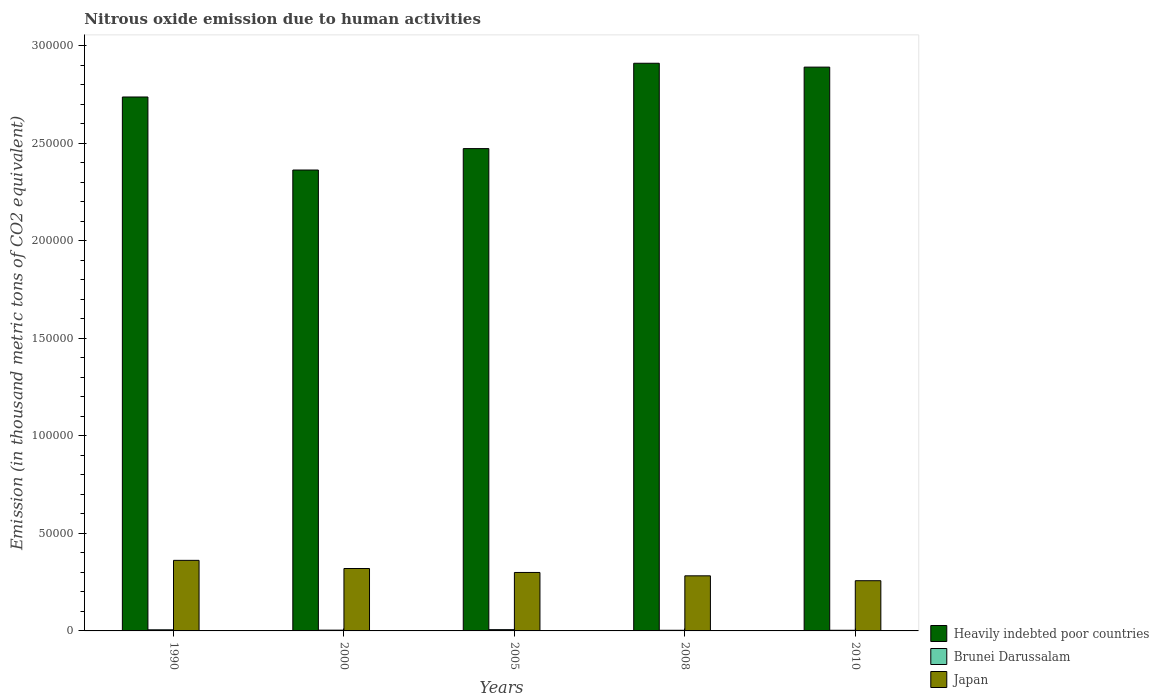How many groups of bars are there?
Your answer should be compact. 5. In how many cases, is the number of bars for a given year not equal to the number of legend labels?
Give a very brief answer. 0. What is the amount of nitrous oxide emitted in Brunei Darussalam in 2000?
Keep it short and to the point. 394.8. Across all years, what is the maximum amount of nitrous oxide emitted in Brunei Darussalam?
Offer a very short reply. 653.7. Across all years, what is the minimum amount of nitrous oxide emitted in Japan?
Offer a very short reply. 2.57e+04. In which year was the amount of nitrous oxide emitted in Japan maximum?
Give a very brief answer. 1990. What is the total amount of nitrous oxide emitted in Japan in the graph?
Your answer should be compact. 1.52e+05. What is the difference between the amount of nitrous oxide emitted in Brunei Darussalam in 2000 and that in 2010?
Offer a terse response. 59.2. What is the difference between the amount of nitrous oxide emitted in Japan in 2000 and the amount of nitrous oxide emitted in Brunei Darussalam in 2005?
Offer a terse response. 3.13e+04. What is the average amount of nitrous oxide emitted in Brunei Darussalam per year?
Your answer should be compact. 457.44. In the year 2000, what is the difference between the amount of nitrous oxide emitted in Brunei Darussalam and amount of nitrous oxide emitted in Japan?
Your answer should be very brief. -3.16e+04. In how many years, is the amount of nitrous oxide emitted in Heavily indebted poor countries greater than 40000 thousand metric tons?
Your answer should be very brief. 5. What is the ratio of the amount of nitrous oxide emitted in Heavily indebted poor countries in 2008 to that in 2010?
Offer a terse response. 1.01. Is the difference between the amount of nitrous oxide emitted in Brunei Darussalam in 2000 and 2010 greater than the difference between the amount of nitrous oxide emitted in Japan in 2000 and 2010?
Your answer should be compact. No. What is the difference between the highest and the second highest amount of nitrous oxide emitted in Brunei Darussalam?
Ensure brevity in your answer.  82.6. What is the difference between the highest and the lowest amount of nitrous oxide emitted in Japan?
Provide a short and direct response. 1.04e+04. Is the sum of the amount of nitrous oxide emitted in Japan in 2000 and 2008 greater than the maximum amount of nitrous oxide emitted in Heavily indebted poor countries across all years?
Offer a terse response. No. What does the 2nd bar from the left in 2010 represents?
Offer a terse response. Brunei Darussalam. How many bars are there?
Your response must be concise. 15. Are all the bars in the graph horizontal?
Provide a succinct answer. No. How many years are there in the graph?
Your response must be concise. 5. What is the difference between two consecutive major ticks on the Y-axis?
Your answer should be compact. 5.00e+04. Are the values on the major ticks of Y-axis written in scientific E-notation?
Ensure brevity in your answer.  No. Does the graph contain grids?
Keep it short and to the point. No. How are the legend labels stacked?
Offer a very short reply. Vertical. What is the title of the graph?
Keep it short and to the point. Nitrous oxide emission due to human activities. Does "Honduras" appear as one of the legend labels in the graph?
Make the answer very short. No. What is the label or title of the X-axis?
Offer a very short reply. Years. What is the label or title of the Y-axis?
Your response must be concise. Emission (in thousand metric tons of CO2 equivalent). What is the Emission (in thousand metric tons of CO2 equivalent) in Heavily indebted poor countries in 1990?
Provide a succinct answer. 2.74e+05. What is the Emission (in thousand metric tons of CO2 equivalent) in Brunei Darussalam in 1990?
Offer a very short reply. 571.1. What is the Emission (in thousand metric tons of CO2 equivalent) of Japan in 1990?
Provide a short and direct response. 3.62e+04. What is the Emission (in thousand metric tons of CO2 equivalent) in Heavily indebted poor countries in 2000?
Give a very brief answer. 2.36e+05. What is the Emission (in thousand metric tons of CO2 equivalent) of Brunei Darussalam in 2000?
Give a very brief answer. 394.8. What is the Emission (in thousand metric tons of CO2 equivalent) in Japan in 2000?
Give a very brief answer. 3.20e+04. What is the Emission (in thousand metric tons of CO2 equivalent) in Heavily indebted poor countries in 2005?
Offer a terse response. 2.47e+05. What is the Emission (in thousand metric tons of CO2 equivalent) in Brunei Darussalam in 2005?
Make the answer very short. 653.7. What is the Emission (in thousand metric tons of CO2 equivalent) in Japan in 2005?
Offer a very short reply. 3.00e+04. What is the Emission (in thousand metric tons of CO2 equivalent) of Heavily indebted poor countries in 2008?
Provide a succinct answer. 2.91e+05. What is the Emission (in thousand metric tons of CO2 equivalent) in Brunei Darussalam in 2008?
Your answer should be compact. 332. What is the Emission (in thousand metric tons of CO2 equivalent) in Japan in 2008?
Ensure brevity in your answer.  2.82e+04. What is the Emission (in thousand metric tons of CO2 equivalent) of Heavily indebted poor countries in 2010?
Provide a short and direct response. 2.89e+05. What is the Emission (in thousand metric tons of CO2 equivalent) in Brunei Darussalam in 2010?
Offer a very short reply. 335.6. What is the Emission (in thousand metric tons of CO2 equivalent) in Japan in 2010?
Keep it short and to the point. 2.57e+04. Across all years, what is the maximum Emission (in thousand metric tons of CO2 equivalent) in Heavily indebted poor countries?
Give a very brief answer. 2.91e+05. Across all years, what is the maximum Emission (in thousand metric tons of CO2 equivalent) of Brunei Darussalam?
Your response must be concise. 653.7. Across all years, what is the maximum Emission (in thousand metric tons of CO2 equivalent) in Japan?
Offer a terse response. 3.62e+04. Across all years, what is the minimum Emission (in thousand metric tons of CO2 equivalent) in Heavily indebted poor countries?
Your answer should be compact. 2.36e+05. Across all years, what is the minimum Emission (in thousand metric tons of CO2 equivalent) of Brunei Darussalam?
Offer a terse response. 332. Across all years, what is the minimum Emission (in thousand metric tons of CO2 equivalent) in Japan?
Make the answer very short. 2.57e+04. What is the total Emission (in thousand metric tons of CO2 equivalent) in Heavily indebted poor countries in the graph?
Your response must be concise. 1.34e+06. What is the total Emission (in thousand metric tons of CO2 equivalent) of Brunei Darussalam in the graph?
Ensure brevity in your answer.  2287.2. What is the total Emission (in thousand metric tons of CO2 equivalent) of Japan in the graph?
Your response must be concise. 1.52e+05. What is the difference between the Emission (in thousand metric tons of CO2 equivalent) of Heavily indebted poor countries in 1990 and that in 2000?
Your answer should be compact. 3.74e+04. What is the difference between the Emission (in thousand metric tons of CO2 equivalent) of Brunei Darussalam in 1990 and that in 2000?
Ensure brevity in your answer.  176.3. What is the difference between the Emission (in thousand metric tons of CO2 equivalent) of Japan in 1990 and that in 2000?
Offer a very short reply. 4179.1. What is the difference between the Emission (in thousand metric tons of CO2 equivalent) of Heavily indebted poor countries in 1990 and that in 2005?
Provide a succinct answer. 2.65e+04. What is the difference between the Emission (in thousand metric tons of CO2 equivalent) of Brunei Darussalam in 1990 and that in 2005?
Your answer should be very brief. -82.6. What is the difference between the Emission (in thousand metric tons of CO2 equivalent) in Japan in 1990 and that in 2005?
Your response must be concise. 6206.6. What is the difference between the Emission (in thousand metric tons of CO2 equivalent) in Heavily indebted poor countries in 1990 and that in 2008?
Give a very brief answer. -1.73e+04. What is the difference between the Emission (in thousand metric tons of CO2 equivalent) in Brunei Darussalam in 1990 and that in 2008?
Your answer should be compact. 239.1. What is the difference between the Emission (in thousand metric tons of CO2 equivalent) of Japan in 1990 and that in 2008?
Give a very brief answer. 7932.2. What is the difference between the Emission (in thousand metric tons of CO2 equivalent) of Heavily indebted poor countries in 1990 and that in 2010?
Your answer should be compact. -1.53e+04. What is the difference between the Emission (in thousand metric tons of CO2 equivalent) of Brunei Darussalam in 1990 and that in 2010?
Provide a short and direct response. 235.5. What is the difference between the Emission (in thousand metric tons of CO2 equivalent) of Japan in 1990 and that in 2010?
Your response must be concise. 1.04e+04. What is the difference between the Emission (in thousand metric tons of CO2 equivalent) in Heavily indebted poor countries in 2000 and that in 2005?
Make the answer very short. -1.10e+04. What is the difference between the Emission (in thousand metric tons of CO2 equivalent) of Brunei Darussalam in 2000 and that in 2005?
Make the answer very short. -258.9. What is the difference between the Emission (in thousand metric tons of CO2 equivalent) of Japan in 2000 and that in 2005?
Give a very brief answer. 2027.5. What is the difference between the Emission (in thousand metric tons of CO2 equivalent) in Heavily indebted poor countries in 2000 and that in 2008?
Provide a short and direct response. -5.47e+04. What is the difference between the Emission (in thousand metric tons of CO2 equivalent) of Brunei Darussalam in 2000 and that in 2008?
Keep it short and to the point. 62.8. What is the difference between the Emission (in thousand metric tons of CO2 equivalent) of Japan in 2000 and that in 2008?
Keep it short and to the point. 3753.1. What is the difference between the Emission (in thousand metric tons of CO2 equivalent) in Heavily indebted poor countries in 2000 and that in 2010?
Ensure brevity in your answer.  -5.28e+04. What is the difference between the Emission (in thousand metric tons of CO2 equivalent) in Brunei Darussalam in 2000 and that in 2010?
Your answer should be very brief. 59.2. What is the difference between the Emission (in thousand metric tons of CO2 equivalent) in Japan in 2000 and that in 2010?
Give a very brief answer. 6256.2. What is the difference between the Emission (in thousand metric tons of CO2 equivalent) of Heavily indebted poor countries in 2005 and that in 2008?
Offer a terse response. -4.38e+04. What is the difference between the Emission (in thousand metric tons of CO2 equivalent) in Brunei Darussalam in 2005 and that in 2008?
Give a very brief answer. 321.7. What is the difference between the Emission (in thousand metric tons of CO2 equivalent) of Japan in 2005 and that in 2008?
Offer a terse response. 1725.6. What is the difference between the Emission (in thousand metric tons of CO2 equivalent) in Heavily indebted poor countries in 2005 and that in 2010?
Your answer should be very brief. -4.18e+04. What is the difference between the Emission (in thousand metric tons of CO2 equivalent) of Brunei Darussalam in 2005 and that in 2010?
Offer a very short reply. 318.1. What is the difference between the Emission (in thousand metric tons of CO2 equivalent) in Japan in 2005 and that in 2010?
Ensure brevity in your answer.  4228.7. What is the difference between the Emission (in thousand metric tons of CO2 equivalent) in Heavily indebted poor countries in 2008 and that in 2010?
Your answer should be compact. 1978. What is the difference between the Emission (in thousand metric tons of CO2 equivalent) in Brunei Darussalam in 2008 and that in 2010?
Give a very brief answer. -3.6. What is the difference between the Emission (in thousand metric tons of CO2 equivalent) in Japan in 2008 and that in 2010?
Offer a terse response. 2503.1. What is the difference between the Emission (in thousand metric tons of CO2 equivalent) of Heavily indebted poor countries in 1990 and the Emission (in thousand metric tons of CO2 equivalent) of Brunei Darussalam in 2000?
Your answer should be compact. 2.73e+05. What is the difference between the Emission (in thousand metric tons of CO2 equivalent) in Heavily indebted poor countries in 1990 and the Emission (in thousand metric tons of CO2 equivalent) in Japan in 2000?
Keep it short and to the point. 2.42e+05. What is the difference between the Emission (in thousand metric tons of CO2 equivalent) in Brunei Darussalam in 1990 and the Emission (in thousand metric tons of CO2 equivalent) in Japan in 2000?
Ensure brevity in your answer.  -3.14e+04. What is the difference between the Emission (in thousand metric tons of CO2 equivalent) of Heavily indebted poor countries in 1990 and the Emission (in thousand metric tons of CO2 equivalent) of Brunei Darussalam in 2005?
Your response must be concise. 2.73e+05. What is the difference between the Emission (in thousand metric tons of CO2 equivalent) of Heavily indebted poor countries in 1990 and the Emission (in thousand metric tons of CO2 equivalent) of Japan in 2005?
Your answer should be very brief. 2.44e+05. What is the difference between the Emission (in thousand metric tons of CO2 equivalent) in Brunei Darussalam in 1990 and the Emission (in thousand metric tons of CO2 equivalent) in Japan in 2005?
Your response must be concise. -2.94e+04. What is the difference between the Emission (in thousand metric tons of CO2 equivalent) of Heavily indebted poor countries in 1990 and the Emission (in thousand metric tons of CO2 equivalent) of Brunei Darussalam in 2008?
Your response must be concise. 2.73e+05. What is the difference between the Emission (in thousand metric tons of CO2 equivalent) in Heavily indebted poor countries in 1990 and the Emission (in thousand metric tons of CO2 equivalent) in Japan in 2008?
Keep it short and to the point. 2.45e+05. What is the difference between the Emission (in thousand metric tons of CO2 equivalent) of Brunei Darussalam in 1990 and the Emission (in thousand metric tons of CO2 equivalent) of Japan in 2008?
Your answer should be very brief. -2.77e+04. What is the difference between the Emission (in thousand metric tons of CO2 equivalent) of Heavily indebted poor countries in 1990 and the Emission (in thousand metric tons of CO2 equivalent) of Brunei Darussalam in 2010?
Offer a terse response. 2.73e+05. What is the difference between the Emission (in thousand metric tons of CO2 equivalent) in Heavily indebted poor countries in 1990 and the Emission (in thousand metric tons of CO2 equivalent) in Japan in 2010?
Your answer should be compact. 2.48e+05. What is the difference between the Emission (in thousand metric tons of CO2 equivalent) in Brunei Darussalam in 1990 and the Emission (in thousand metric tons of CO2 equivalent) in Japan in 2010?
Give a very brief answer. -2.52e+04. What is the difference between the Emission (in thousand metric tons of CO2 equivalent) of Heavily indebted poor countries in 2000 and the Emission (in thousand metric tons of CO2 equivalent) of Brunei Darussalam in 2005?
Your answer should be compact. 2.36e+05. What is the difference between the Emission (in thousand metric tons of CO2 equivalent) of Heavily indebted poor countries in 2000 and the Emission (in thousand metric tons of CO2 equivalent) of Japan in 2005?
Offer a terse response. 2.06e+05. What is the difference between the Emission (in thousand metric tons of CO2 equivalent) in Brunei Darussalam in 2000 and the Emission (in thousand metric tons of CO2 equivalent) in Japan in 2005?
Give a very brief answer. -2.96e+04. What is the difference between the Emission (in thousand metric tons of CO2 equivalent) in Heavily indebted poor countries in 2000 and the Emission (in thousand metric tons of CO2 equivalent) in Brunei Darussalam in 2008?
Offer a very short reply. 2.36e+05. What is the difference between the Emission (in thousand metric tons of CO2 equivalent) of Heavily indebted poor countries in 2000 and the Emission (in thousand metric tons of CO2 equivalent) of Japan in 2008?
Offer a terse response. 2.08e+05. What is the difference between the Emission (in thousand metric tons of CO2 equivalent) of Brunei Darussalam in 2000 and the Emission (in thousand metric tons of CO2 equivalent) of Japan in 2008?
Your response must be concise. -2.78e+04. What is the difference between the Emission (in thousand metric tons of CO2 equivalent) of Heavily indebted poor countries in 2000 and the Emission (in thousand metric tons of CO2 equivalent) of Brunei Darussalam in 2010?
Provide a short and direct response. 2.36e+05. What is the difference between the Emission (in thousand metric tons of CO2 equivalent) in Heavily indebted poor countries in 2000 and the Emission (in thousand metric tons of CO2 equivalent) in Japan in 2010?
Give a very brief answer. 2.11e+05. What is the difference between the Emission (in thousand metric tons of CO2 equivalent) of Brunei Darussalam in 2000 and the Emission (in thousand metric tons of CO2 equivalent) of Japan in 2010?
Your answer should be compact. -2.53e+04. What is the difference between the Emission (in thousand metric tons of CO2 equivalent) of Heavily indebted poor countries in 2005 and the Emission (in thousand metric tons of CO2 equivalent) of Brunei Darussalam in 2008?
Offer a terse response. 2.47e+05. What is the difference between the Emission (in thousand metric tons of CO2 equivalent) in Heavily indebted poor countries in 2005 and the Emission (in thousand metric tons of CO2 equivalent) in Japan in 2008?
Your response must be concise. 2.19e+05. What is the difference between the Emission (in thousand metric tons of CO2 equivalent) in Brunei Darussalam in 2005 and the Emission (in thousand metric tons of CO2 equivalent) in Japan in 2008?
Give a very brief answer. -2.76e+04. What is the difference between the Emission (in thousand metric tons of CO2 equivalent) of Heavily indebted poor countries in 2005 and the Emission (in thousand metric tons of CO2 equivalent) of Brunei Darussalam in 2010?
Your response must be concise. 2.47e+05. What is the difference between the Emission (in thousand metric tons of CO2 equivalent) in Heavily indebted poor countries in 2005 and the Emission (in thousand metric tons of CO2 equivalent) in Japan in 2010?
Offer a terse response. 2.21e+05. What is the difference between the Emission (in thousand metric tons of CO2 equivalent) of Brunei Darussalam in 2005 and the Emission (in thousand metric tons of CO2 equivalent) of Japan in 2010?
Give a very brief answer. -2.51e+04. What is the difference between the Emission (in thousand metric tons of CO2 equivalent) in Heavily indebted poor countries in 2008 and the Emission (in thousand metric tons of CO2 equivalent) in Brunei Darussalam in 2010?
Ensure brevity in your answer.  2.91e+05. What is the difference between the Emission (in thousand metric tons of CO2 equivalent) of Heavily indebted poor countries in 2008 and the Emission (in thousand metric tons of CO2 equivalent) of Japan in 2010?
Your response must be concise. 2.65e+05. What is the difference between the Emission (in thousand metric tons of CO2 equivalent) in Brunei Darussalam in 2008 and the Emission (in thousand metric tons of CO2 equivalent) in Japan in 2010?
Offer a very short reply. -2.54e+04. What is the average Emission (in thousand metric tons of CO2 equivalent) in Heavily indebted poor countries per year?
Offer a terse response. 2.67e+05. What is the average Emission (in thousand metric tons of CO2 equivalent) in Brunei Darussalam per year?
Offer a very short reply. 457.44. What is the average Emission (in thousand metric tons of CO2 equivalent) of Japan per year?
Provide a short and direct response. 3.04e+04. In the year 1990, what is the difference between the Emission (in thousand metric tons of CO2 equivalent) in Heavily indebted poor countries and Emission (in thousand metric tons of CO2 equivalent) in Brunei Darussalam?
Provide a succinct answer. 2.73e+05. In the year 1990, what is the difference between the Emission (in thousand metric tons of CO2 equivalent) in Heavily indebted poor countries and Emission (in thousand metric tons of CO2 equivalent) in Japan?
Make the answer very short. 2.38e+05. In the year 1990, what is the difference between the Emission (in thousand metric tons of CO2 equivalent) in Brunei Darussalam and Emission (in thousand metric tons of CO2 equivalent) in Japan?
Ensure brevity in your answer.  -3.56e+04. In the year 2000, what is the difference between the Emission (in thousand metric tons of CO2 equivalent) in Heavily indebted poor countries and Emission (in thousand metric tons of CO2 equivalent) in Brunei Darussalam?
Give a very brief answer. 2.36e+05. In the year 2000, what is the difference between the Emission (in thousand metric tons of CO2 equivalent) in Heavily indebted poor countries and Emission (in thousand metric tons of CO2 equivalent) in Japan?
Ensure brevity in your answer.  2.04e+05. In the year 2000, what is the difference between the Emission (in thousand metric tons of CO2 equivalent) of Brunei Darussalam and Emission (in thousand metric tons of CO2 equivalent) of Japan?
Offer a terse response. -3.16e+04. In the year 2005, what is the difference between the Emission (in thousand metric tons of CO2 equivalent) in Heavily indebted poor countries and Emission (in thousand metric tons of CO2 equivalent) in Brunei Darussalam?
Your response must be concise. 2.47e+05. In the year 2005, what is the difference between the Emission (in thousand metric tons of CO2 equivalent) of Heavily indebted poor countries and Emission (in thousand metric tons of CO2 equivalent) of Japan?
Ensure brevity in your answer.  2.17e+05. In the year 2005, what is the difference between the Emission (in thousand metric tons of CO2 equivalent) of Brunei Darussalam and Emission (in thousand metric tons of CO2 equivalent) of Japan?
Your answer should be compact. -2.93e+04. In the year 2008, what is the difference between the Emission (in thousand metric tons of CO2 equivalent) of Heavily indebted poor countries and Emission (in thousand metric tons of CO2 equivalent) of Brunei Darussalam?
Provide a succinct answer. 2.91e+05. In the year 2008, what is the difference between the Emission (in thousand metric tons of CO2 equivalent) in Heavily indebted poor countries and Emission (in thousand metric tons of CO2 equivalent) in Japan?
Your answer should be compact. 2.63e+05. In the year 2008, what is the difference between the Emission (in thousand metric tons of CO2 equivalent) of Brunei Darussalam and Emission (in thousand metric tons of CO2 equivalent) of Japan?
Give a very brief answer. -2.79e+04. In the year 2010, what is the difference between the Emission (in thousand metric tons of CO2 equivalent) of Heavily indebted poor countries and Emission (in thousand metric tons of CO2 equivalent) of Brunei Darussalam?
Your answer should be compact. 2.89e+05. In the year 2010, what is the difference between the Emission (in thousand metric tons of CO2 equivalent) of Heavily indebted poor countries and Emission (in thousand metric tons of CO2 equivalent) of Japan?
Your response must be concise. 2.63e+05. In the year 2010, what is the difference between the Emission (in thousand metric tons of CO2 equivalent) in Brunei Darussalam and Emission (in thousand metric tons of CO2 equivalent) in Japan?
Provide a short and direct response. -2.54e+04. What is the ratio of the Emission (in thousand metric tons of CO2 equivalent) in Heavily indebted poor countries in 1990 to that in 2000?
Your response must be concise. 1.16. What is the ratio of the Emission (in thousand metric tons of CO2 equivalent) in Brunei Darussalam in 1990 to that in 2000?
Keep it short and to the point. 1.45. What is the ratio of the Emission (in thousand metric tons of CO2 equivalent) in Japan in 1990 to that in 2000?
Keep it short and to the point. 1.13. What is the ratio of the Emission (in thousand metric tons of CO2 equivalent) of Heavily indebted poor countries in 1990 to that in 2005?
Ensure brevity in your answer.  1.11. What is the ratio of the Emission (in thousand metric tons of CO2 equivalent) of Brunei Darussalam in 1990 to that in 2005?
Ensure brevity in your answer.  0.87. What is the ratio of the Emission (in thousand metric tons of CO2 equivalent) in Japan in 1990 to that in 2005?
Provide a succinct answer. 1.21. What is the ratio of the Emission (in thousand metric tons of CO2 equivalent) of Heavily indebted poor countries in 1990 to that in 2008?
Keep it short and to the point. 0.94. What is the ratio of the Emission (in thousand metric tons of CO2 equivalent) of Brunei Darussalam in 1990 to that in 2008?
Provide a succinct answer. 1.72. What is the ratio of the Emission (in thousand metric tons of CO2 equivalent) of Japan in 1990 to that in 2008?
Make the answer very short. 1.28. What is the ratio of the Emission (in thousand metric tons of CO2 equivalent) of Heavily indebted poor countries in 1990 to that in 2010?
Offer a very short reply. 0.95. What is the ratio of the Emission (in thousand metric tons of CO2 equivalent) of Brunei Darussalam in 1990 to that in 2010?
Your response must be concise. 1.7. What is the ratio of the Emission (in thousand metric tons of CO2 equivalent) in Japan in 1990 to that in 2010?
Offer a very short reply. 1.41. What is the ratio of the Emission (in thousand metric tons of CO2 equivalent) of Heavily indebted poor countries in 2000 to that in 2005?
Ensure brevity in your answer.  0.96. What is the ratio of the Emission (in thousand metric tons of CO2 equivalent) in Brunei Darussalam in 2000 to that in 2005?
Offer a very short reply. 0.6. What is the ratio of the Emission (in thousand metric tons of CO2 equivalent) of Japan in 2000 to that in 2005?
Ensure brevity in your answer.  1.07. What is the ratio of the Emission (in thousand metric tons of CO2 equivalent) of Heavily indebted poor countries in 2000 to that in 2008?
Your answer should be compact. 0.81. What is the ratio of the Emission (in thousand metric tons of CO2 equivalent) in Brunei Darussalam in 2000 to that in 2008?
Your answer should be very brief. 1.19. What is the ratio of the Emission (in thousand metric tons of CO2 equivalent) in Japan in 2000 to that in 2008?
Your answer should be compact. 1.13. What is the ratio of the Emission (in thousand metric tons of CO2 equivalent) in Heavily indebted poor countries in 2000 to that in 2010?
Ensure brevity in your answer.  0.82. What is the ratio of the Emission (in thousand metric tons of CO2 equivalent) in Brunei Darussalam in 2000 to that in 2010?
Offer a terse response. 1.18. What is the ratio of the Emission (in thousand metric tons of CO2 equivalent) in Japan in 2000 to that in 2010?
Provide a succinct answer. 1.24. What is the ratio of the Emission (in thousand metric tons of CO2 equivalent) of Heavily indebted poor countries in 2005 to that in 2008?
Your answer should be very brief. 0.85. What is the ratio of the Emission (in thousand metric tons of CO2 equivalent) of Brunei Darussalam in 2005 to that in 2008?
Provide a succinct answer. 1.97. What is the ratio of the Emission (in thousand metric tons of CO2 equivalent) in Japan in 2005 to that in 2008?
Make the answer very short. 1.06. What is the ratio of the Emission (in thousand metric tons of CO2 equivalent) in Heavily indebted poor countries in 2005 to that in 2010?
Ensure brevity in your answer.  0.86. What is the ratio of the Emission (in thousand metric tons of CO2 equivalent) in Brunei Darussalam in 2005 to that in 2010?
Your response must be concise. 1.95. What is the ratio of the Emission (in thousand metric tons of CO2 equivalent) in Japan in 2005 to that in 2010?
Give a very brief answer. 1.16. What is the ratio of the Emission (in thousand metric tons of CO2 equivalent) of Heavily indebted poor countries in 2008 to that in 2010?
Provide a short and direct response. 1.01. What is the ratio of the Emission (in thousand metric tons of CO2 equivalent) of Brunei Darussalam in 2008 to that in 2010?
Ensure brevity in your answer.  0.99. What is the ratio of the Emission (in thousand metric tons of CO2 equivalent) in Japan in 2008 to that in 2010?
Offer a very short reply. 1.1. What is the difference between the highest and the second highest Emission (in thousand metric tons of CO2 equivalent) in Heavily indebted poor countries?
Your response must be concise. 1978. What is the difference between the highest and the second highest Emission (in thousand metric tons of CO2 equivalent) of Brunei Darussalam?
Provide a succinct answer. 82.6. What is the difference between the highest and the second highest Emission (in thousand metric tons of CO2 equivalent) of Japan?
Keep it short and to the point. 4179.1. What is the difference between the highest and the lowest Emission (in thousand metric tons of CO2 equivalent) of Heavily indebted poor countries?
Your answer should be very brief. 5.47e+04. What is the difference between the highest and the lowest Emission (in thousand metric tons of CO2 equivalent) in Brunei Darussalam?
Provide a short and direct response. 321.7. What is the difference between the highest and the lowest Emission (in thousand metric tons of CO2 equivalent) of Japan?
Give a very brief answer. 1.04e+04. 